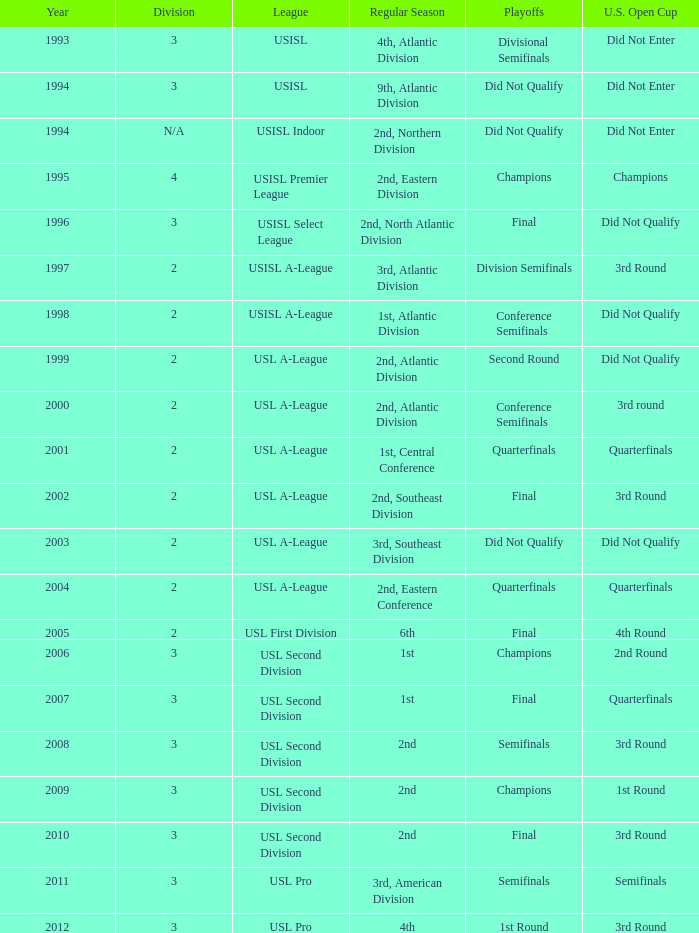What are the playoffs for the regular season, with the 1st place team in the atlantic division? Conference Semifinals. 